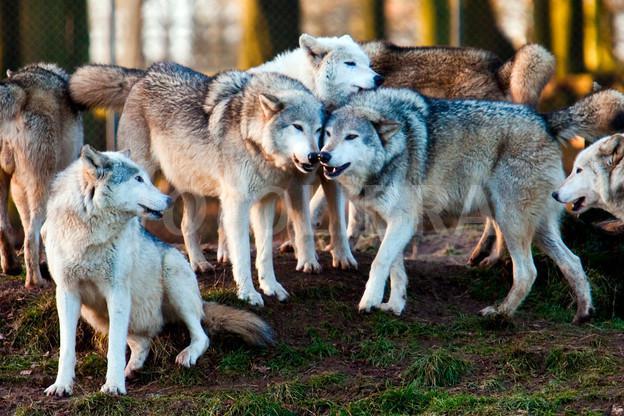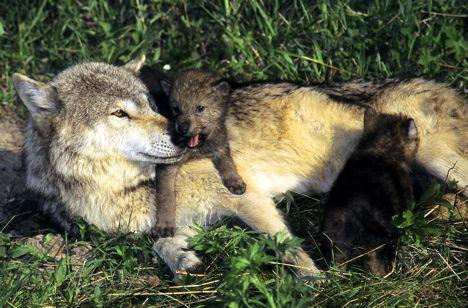The first image is the image on the left, the second image is the image on the right. Evaluate the accuracy of this statement regarding the images: "In the right image there are three adult wolves.". Is it true? Answer yes or no. No. The first image is the image on the left, the second image is the image on the right. Evaluate the accuracy of this statement regarding the images: "One image contains four wolves, several of which are perched on large grey rocks, and several facing rightward with heads high.". Is it true? Answer yes or no. No. 